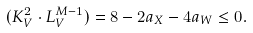<formula> <loc_0><loc_0><loc_500><loc_500>( K ^ { 2 } _ { V } \cdot L ^ { M - 1 } _ { V } ) = 8 - 2 a _ { X } - 4 a _ { W } \leq 0 .</formula> 